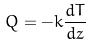Convert formula to latex. <formula><loc_0><loc_0><loc_500><loc_500>Q = - k \frac { d T } { d z }</formula> 